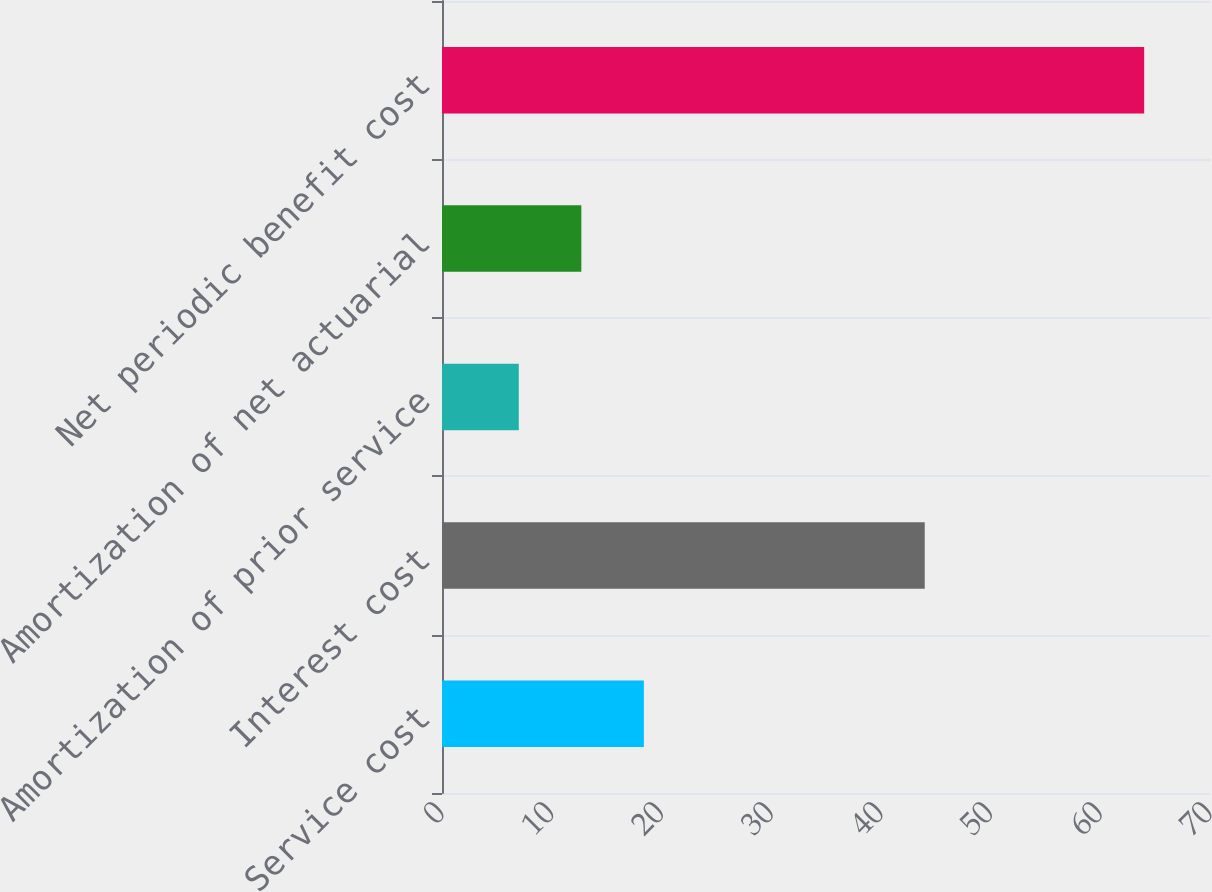Convert chart. <chart><loc_0><loc_0><loc_500><loc_500><bar_chart><fcel>Service cost<fcel>Interest cost<fcel>Amortization of prior service<fcel>Amortization of net actuarial<fcel>Net periodic benefit cost<nl><fcel>18.4<fcel>44<fcel>7<fcel>12.7<fcel>64<nl></chart> 